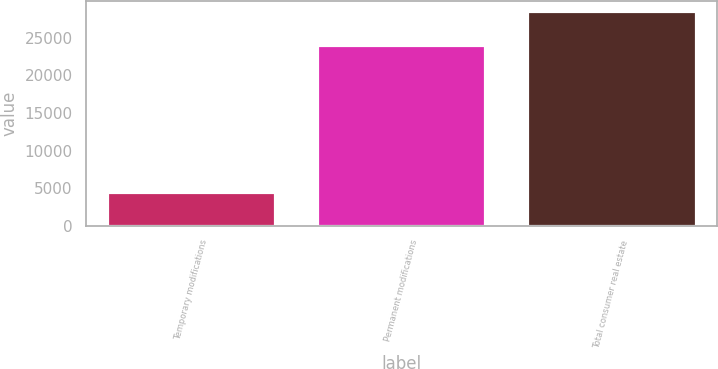<chart> <loc_0><loc_0><loc_500><loc_500><bar_chart><fcel>Temporary modifications<fcel>Permanent modifications<fcel>Total consumer real estate<nl><fcel>4469<fcel>24055<fcel>28524<nl></chart> 